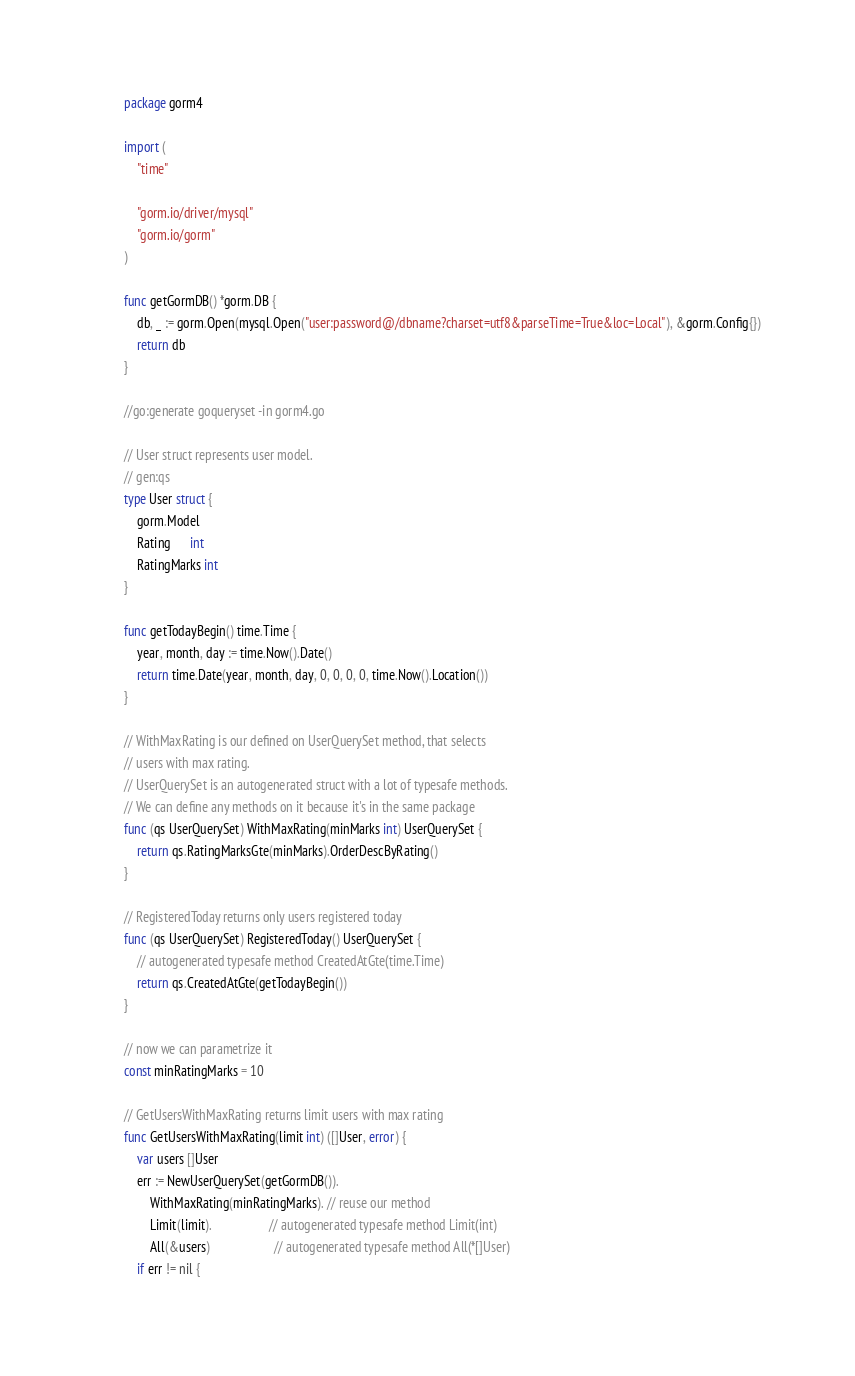<code> <loc_0><loc_0><loc_500><loc_500><_Go_>package gorm4

import (
	"time"

	"gorm.io/driver/mysql"
	"gorm.io/gorm"
)

func getGormDB() *gorm.DB {
	db, _ := gorm.Open(mysql.Open("user:password@/dbname?charset=utf8&parseTime=True&loc=Local"), &gorm.Config{})
	return db
}

//go:generate goqueryset -in gorm4.go

// User struct represents user model.
// gen:qs
type User struct {
	gorm.Model
	Rating      int
	RatingMarks int
}

func getTodayBegin() time.Time {
	year, month, day := time.Now().Date()
	return time.Date(year, month, day, 0, 0, 0, 0, time.Now().Location())
}

// WithMaxRating is our defined on UserQuerySet method, that selects
// users with max rating.
// UserQuerySet is an autogenerated struct with a lot of typesafe methods.
// We can define any methods on it because it's in the same package
func (qs UserQuerySet) WithMaxRating(minMarks int) UserQuerySet {
	return qs.RatingMarksGte(minMarks).OrderDescByRating()
}

// RegisteredToday returns only users registered today
func (qs UserQuerySet) RegisteredToday() UserQuerySet {
	// autogenerated typesafe method CreatedAtGte(time.Time)
	return qs.CreatedAtGte(getTodayBegin())
}

// now we can parametrize it
const minRatingMarks = 10

// GetUsersWithMaxRating returns limit users with max rating
func GetUsersWithMaxRating(limit int) ([]User, error) {
	var users []User
	err := NewUserQuerySet(getGormDB()).
		WithMaxRating(minRatingMarks). // reuse our method
		Limit(limit).                  // autogenerated typesafe method Limit(int)
		All(&users)                    // autogenerated typesafe method All(*[]User)
	if err != nil {</code> 